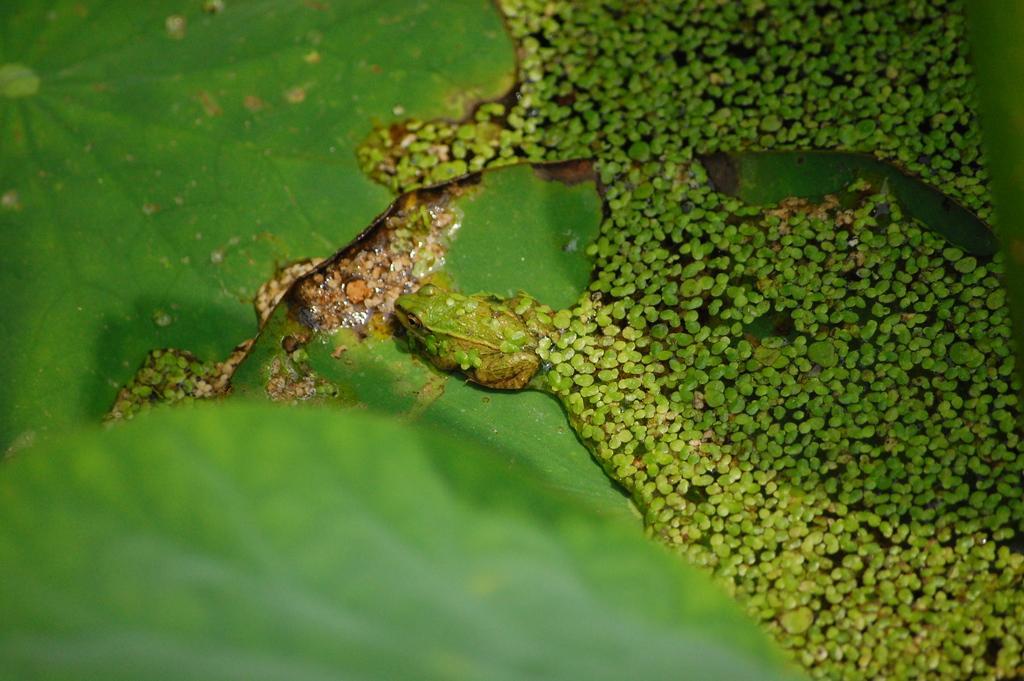Could you give a brief overview of what you see in this image? In this image I can see few leaves in green color and I can also see the frog on the leaf and few objects on the water. 